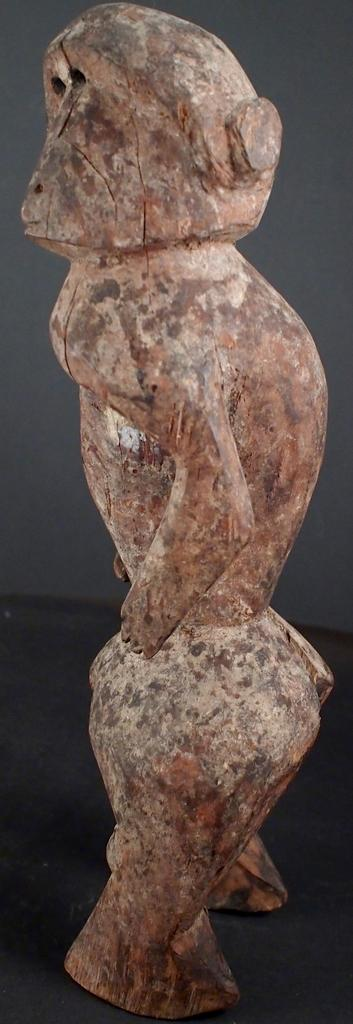What is the main subject of the image? There is a sculpture in the image. Where is the sculpture located? The sculpture is placed on the ground. How deep is the hole in the sculpture in the image? There is no hole present in the sculpture in the image. What type of straw is depicted in the sculpture? The sculpture does not depict a straw; it is a standalone sculpture. 